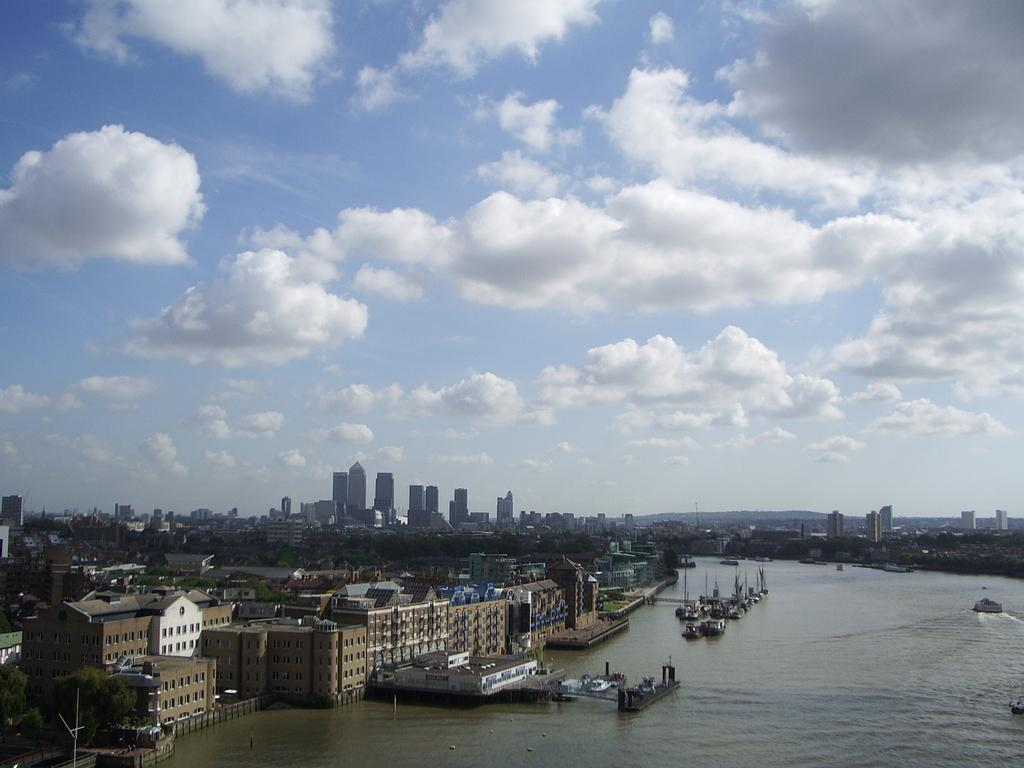What is on the water in the image? There are boats on the water in the image. What type of natural elements can be seen in the image? Trees are visible in the image. What man-made structures are present in the image? There are buildings in the image. What else can be seen in the image besides the boats, trees, and buildings? There are objects in the image. What is visible in the background of the image? The sky is visible in the background of the image. What type of brush can be seen in the image? There is no brush present in the image. What branch is visible in the image? There is no branch visible in the image. What bottle is shown in the image? There is no bottle present in the image. What type of brush can be seen in the image? There is no brush present in the image. What branch is visible in the image? There is no branch visible in the image. What bottle is shown in the image? There is no bottle present in the image. 